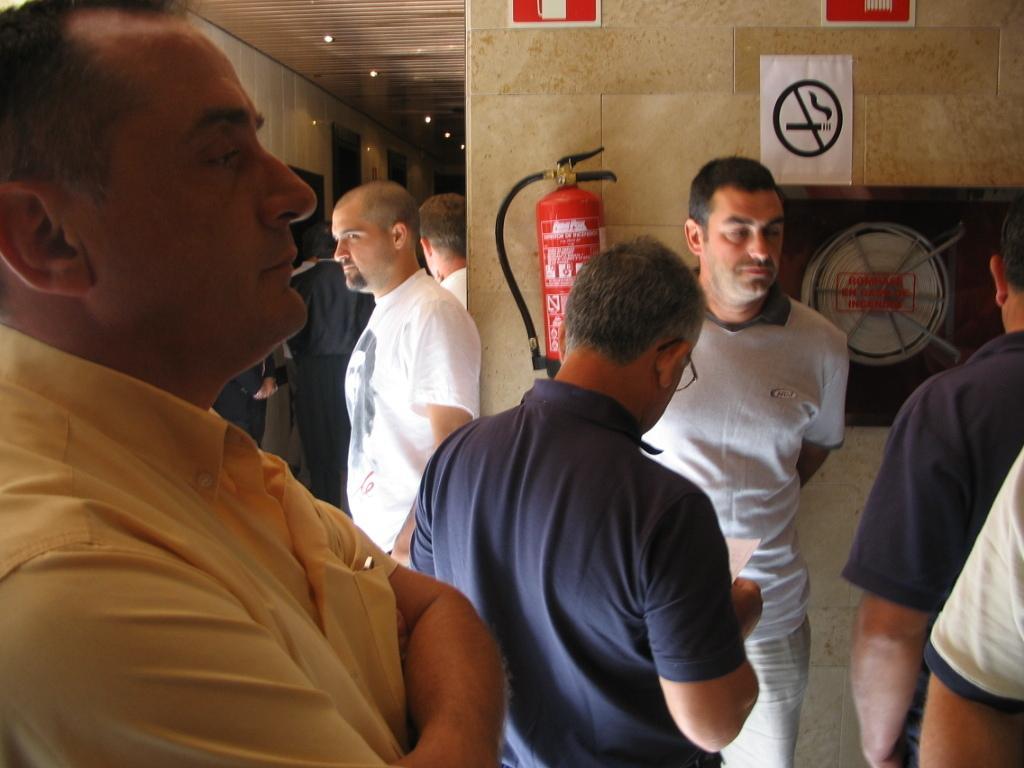Please provide a concise description of this image. In this image, there are a few people. We can see the wall with a fire extinguisher and an object. We can also see some posters and frames. We can see the roof with some lights. 